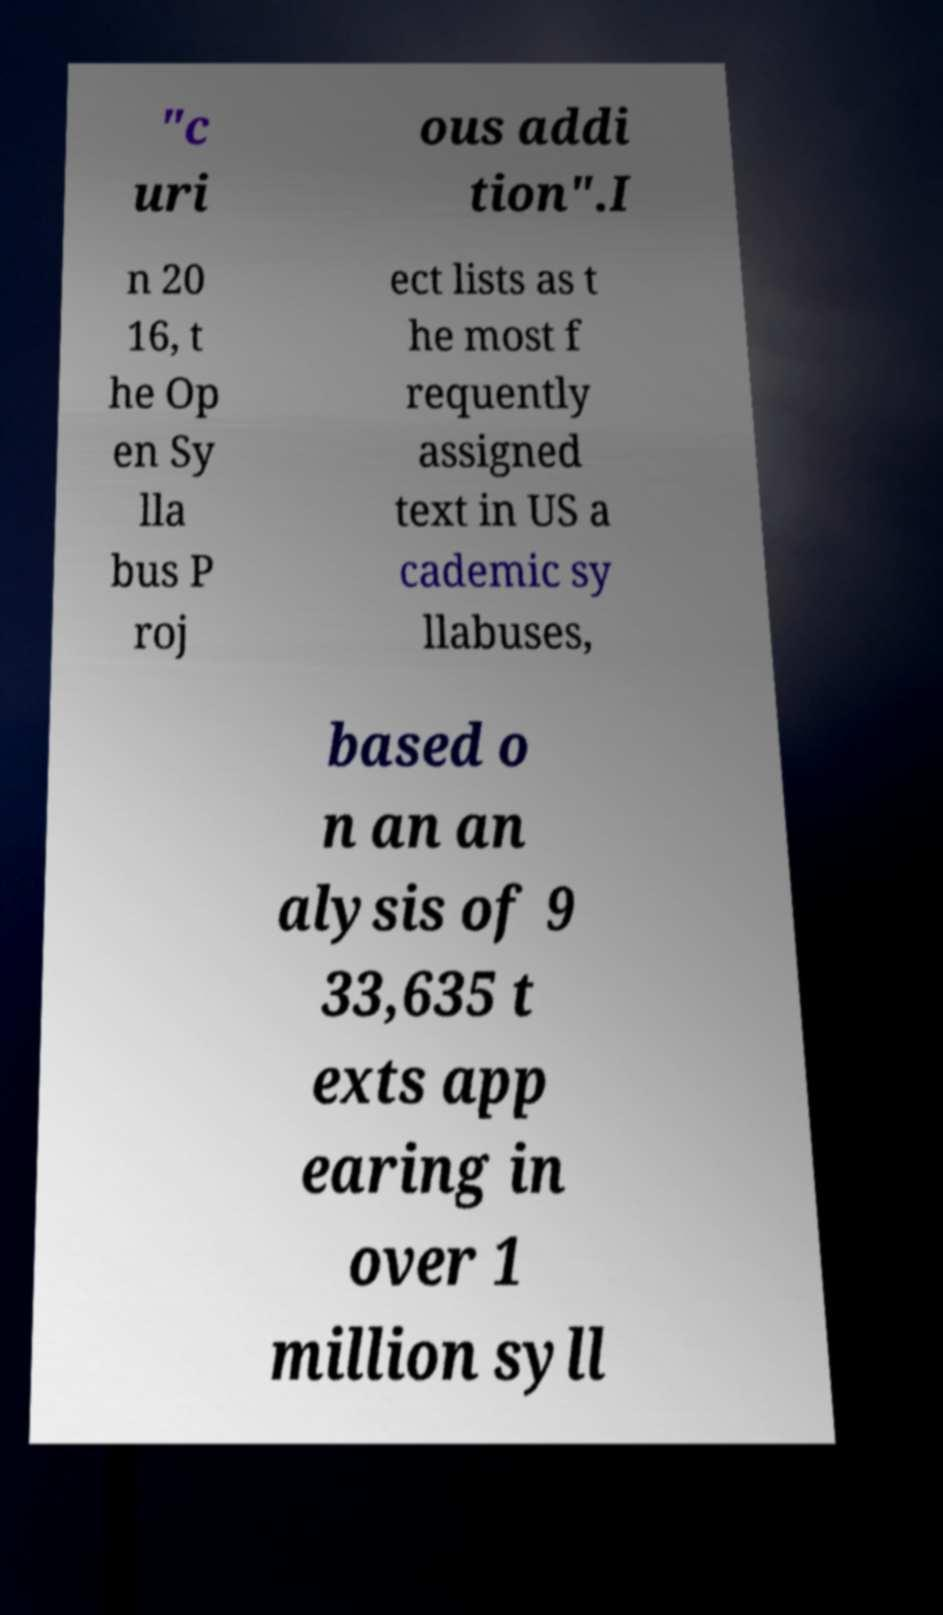Can you accurately transcribe the text from the provided image for me? "c uri ous addi tion".I n 20 16, t he Op en Sy lla bus P roj ect lists as t he most f requently assigned text in US a cademic sy llabuses, based o n an an alysis of 9 33,635 t exts app earing in over 1 million syll 